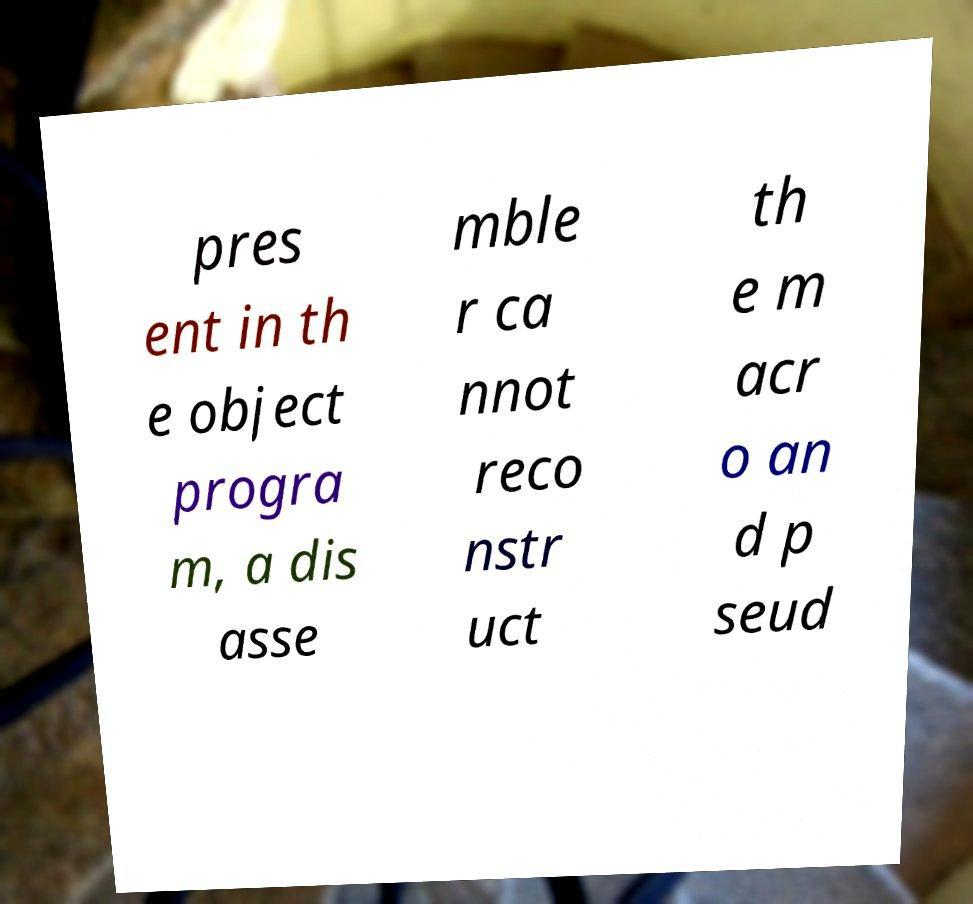I need the written content from this picture converted into text. Can you do that? pres ent in th e object progra m, a dis asse mble r ca nnot reco nstr uct th e m acr o an d p seud 